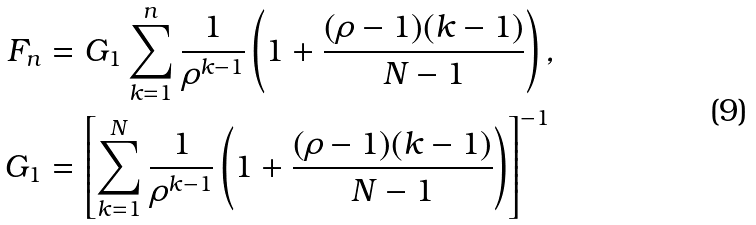Convert formula to latex. <formula><loc_0><loc_0><loc_500><loc_500>F _ { n } & = G _ { 1 } \sum _ { k = 1 } ^ { n } \frac { 1 } { \rho ^ { k - 1 } } \left ( 1 + \frac { ( \rho - 1 ) ( k - 1 ) } { N - 1 } \right ) , \\ G _ { 1 } & = \left [ \sum _ { k = 1 } ^ { N } \frac { 1 } { \rho ^ { k - 1 } } \left ( 1 + \frac { ( \rho - 1 ) ( k - 1 ) } { N - 1 } \right ) \right ] ^ { - 1 }</formula> 